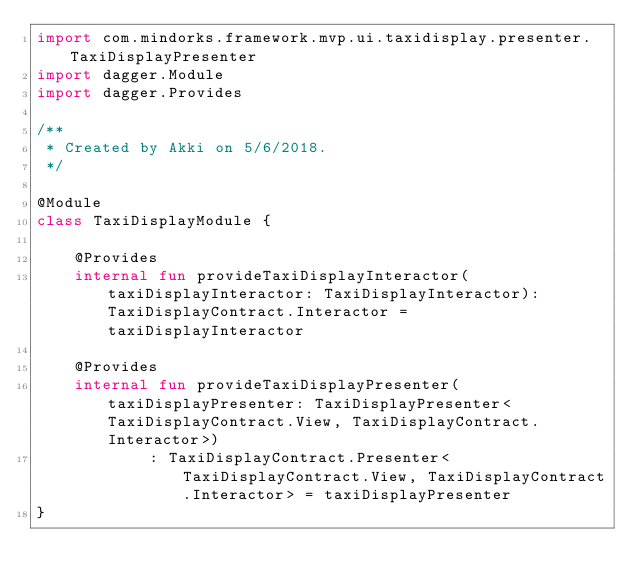Convert code to text. <code><loc_0><loc_0><loc_500><loc_500><_Kotlin_>import com.mindorks.framework.mvp.ui.taxidisplay.presenter.TaxiDisplayPresenter
import dagger.Module
import dagger.Provides

/**
 * Created by Akki on 5/6/2018.
 */

@Module
class TaxiDisplayModule {

    @Provides
    internal fun provideTaxiDisplayInteractor(taxiDisplayInteractor: TaxiDisplayInteractor): TaxiDisplayContract.Interactor = taxiDisplayInteractor

    @Provides
    internal fun provideTaxiDisplayPresenter(taxiDisplayPresenter: TaxiDisplayPresenter<TaxiDisplayContract.View, TaxiDisplayContract.Interactor>)
            : TaxiDisplayContract.Presenter<TaxiDisplayContract.View, TaxiDisplayContract.Interactor> = taxiDisplayPresenter
}

</code> 